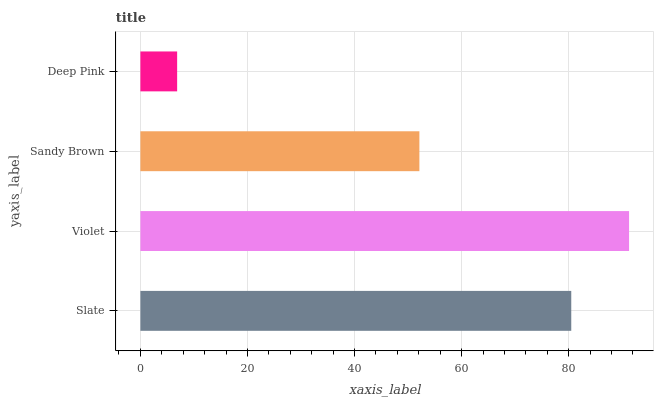Is Deep Pink the minimum?
Answer yes or no. Yes. Is Violet the maximum?
Answer yes or no. Yes. Is Sandy Brown the minimum?
Answer yes or no. No. Is Sandy Brown the maximum?
Answer yes or no. No. Is Violet greater than Sandy Brown?
Answer yes or no. Yes. Is Sandy Brown less than Violet?
Answer yes or no. Yes. Is Sandy Brown greater than Violet?
Answer yes or no. No. Is Violet less than Sandy Brown?
Answer yes or no. No. Is Slate the high median?
Answer yes or no. Yes. Is Sandy Brown the low median?
Answer yes or no. Yes. Is Deep Pink the high median?
Answer yes or no. No. Is Deep Pink the low median?
Answer yes or no. No. 